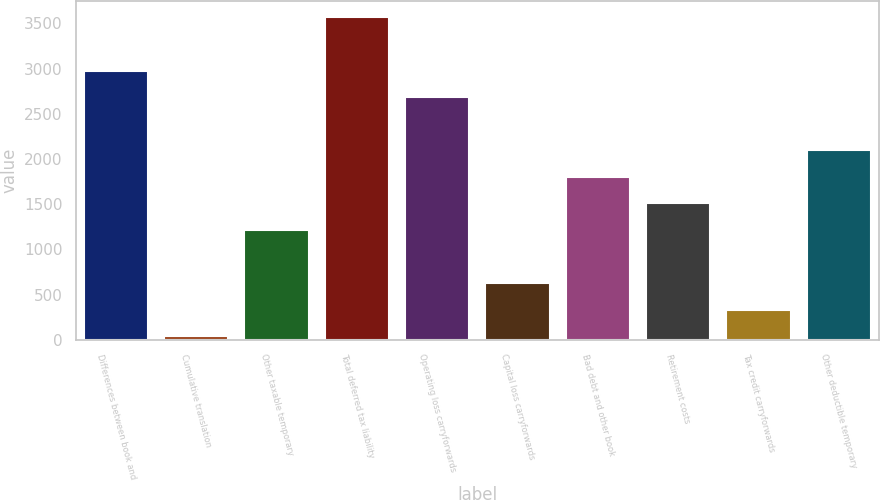<chart> <loc_0><loc_0><loc_500><loc_500><bar_chart><fcel>Differences between book and<fcel>Cumulative translation<fcel>Other taxable temporary<fcel>Total deferred tax liability<fcel>Operating loss carryforwards<fcel>Capital loss carryforwards<fcel>Bad debt and other book<fcel>Retirement costs<fcel>Tax credit carryforwards<fcel>Other deductible temporary<nl><fcel>2978<fcel>39<fcel>1214.6<fcel>3565.8<fcel>2684.1<fcel>626.8<fcel>1802.4<fcel>1508.5<fcel>332.9<fcel>2096.3<nl></chart> 